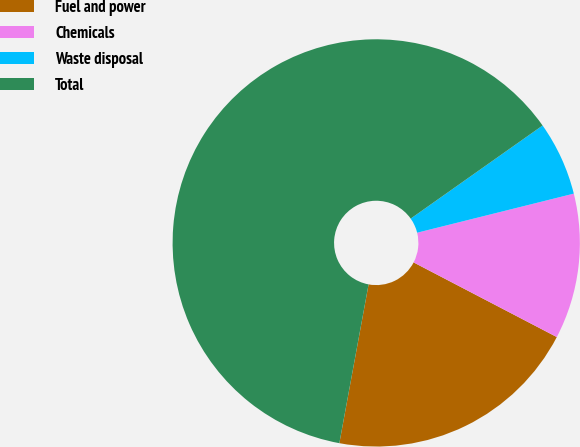<chart> <loc_0><loc_0><loc_500><loc_500><pie_chart><fcel>Fuel and power<fcel>Chemicals<fcel>Waste disposal<fcel>Total<nl><fcel>20.25%<fcel>11.54%<fcel>5.89%<fcel>62.32%<nl></chart> 